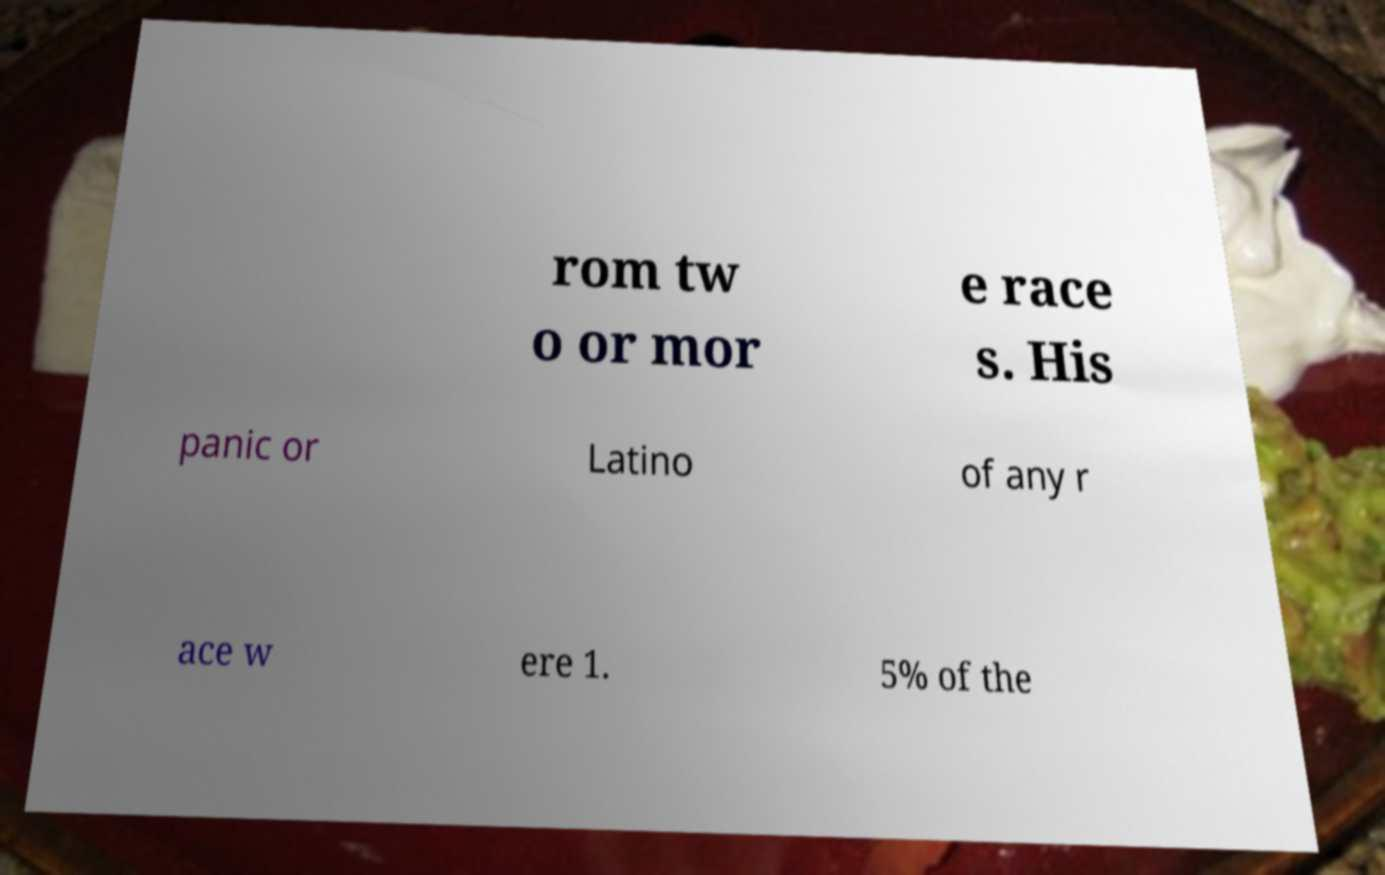There's text embedded in this image that I need extracted. Can you transcribe it verbatim? rom tw o or mor e race s. His panic or Latino of any r ace w ere 1. 5% of the 